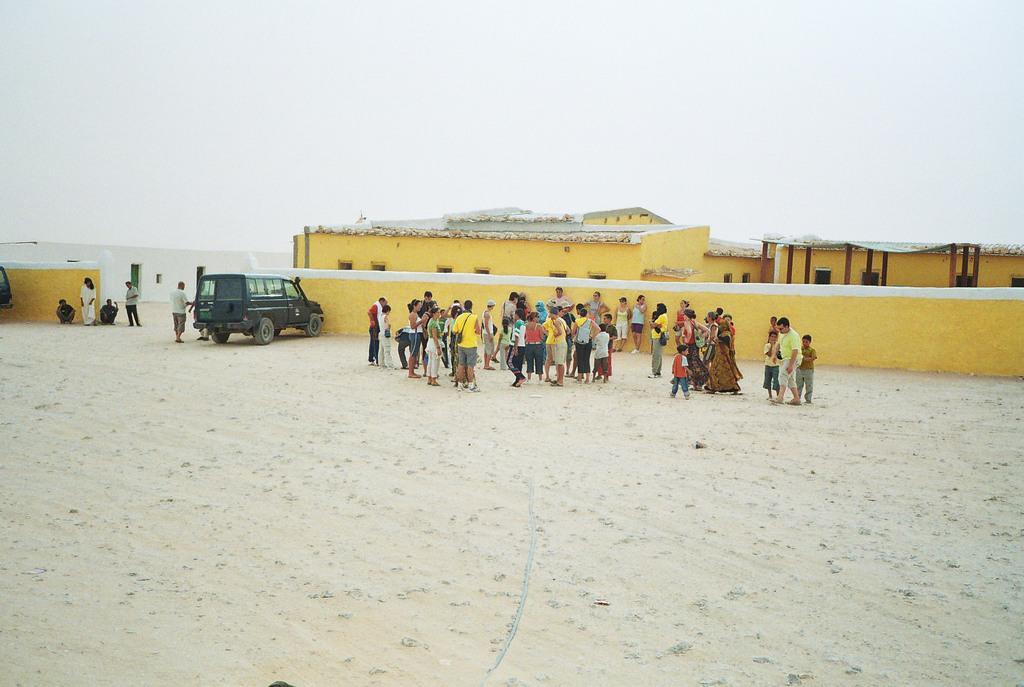In one or two sentences, can you explain what this image depicts? In the foreground of the picture there is sand. In the center of the picture there are people, wall, car and houses. Sky is cloudy. 